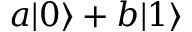<formula> <loc_0><loc_0><loc_500><loc_500>a | 0 \rangle + b | 1 \rangle</formula> 